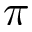Convert formula to latex. <formula><loc_0><loc_0><loc_500><loc_500>\pi</formula> 